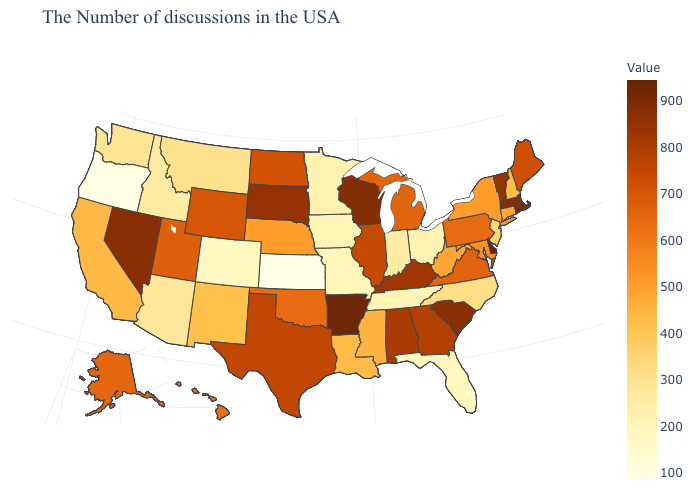Which states have the lowest value in the Northeast?
Give a very brief answer. New Jersey. Does the map have missing data?
Short answer required. No. Does Kansas have the lowest value in the USA?
Be succinct. Yes. Which states hav the highest value in the South?
Short answer required. Delaware. Which states have the lowest value in the MidWest?
Be succinct. Kansas. Among the states that border Rhode Island , which have the highest value?
Write a very short answer. Massachusetts. 